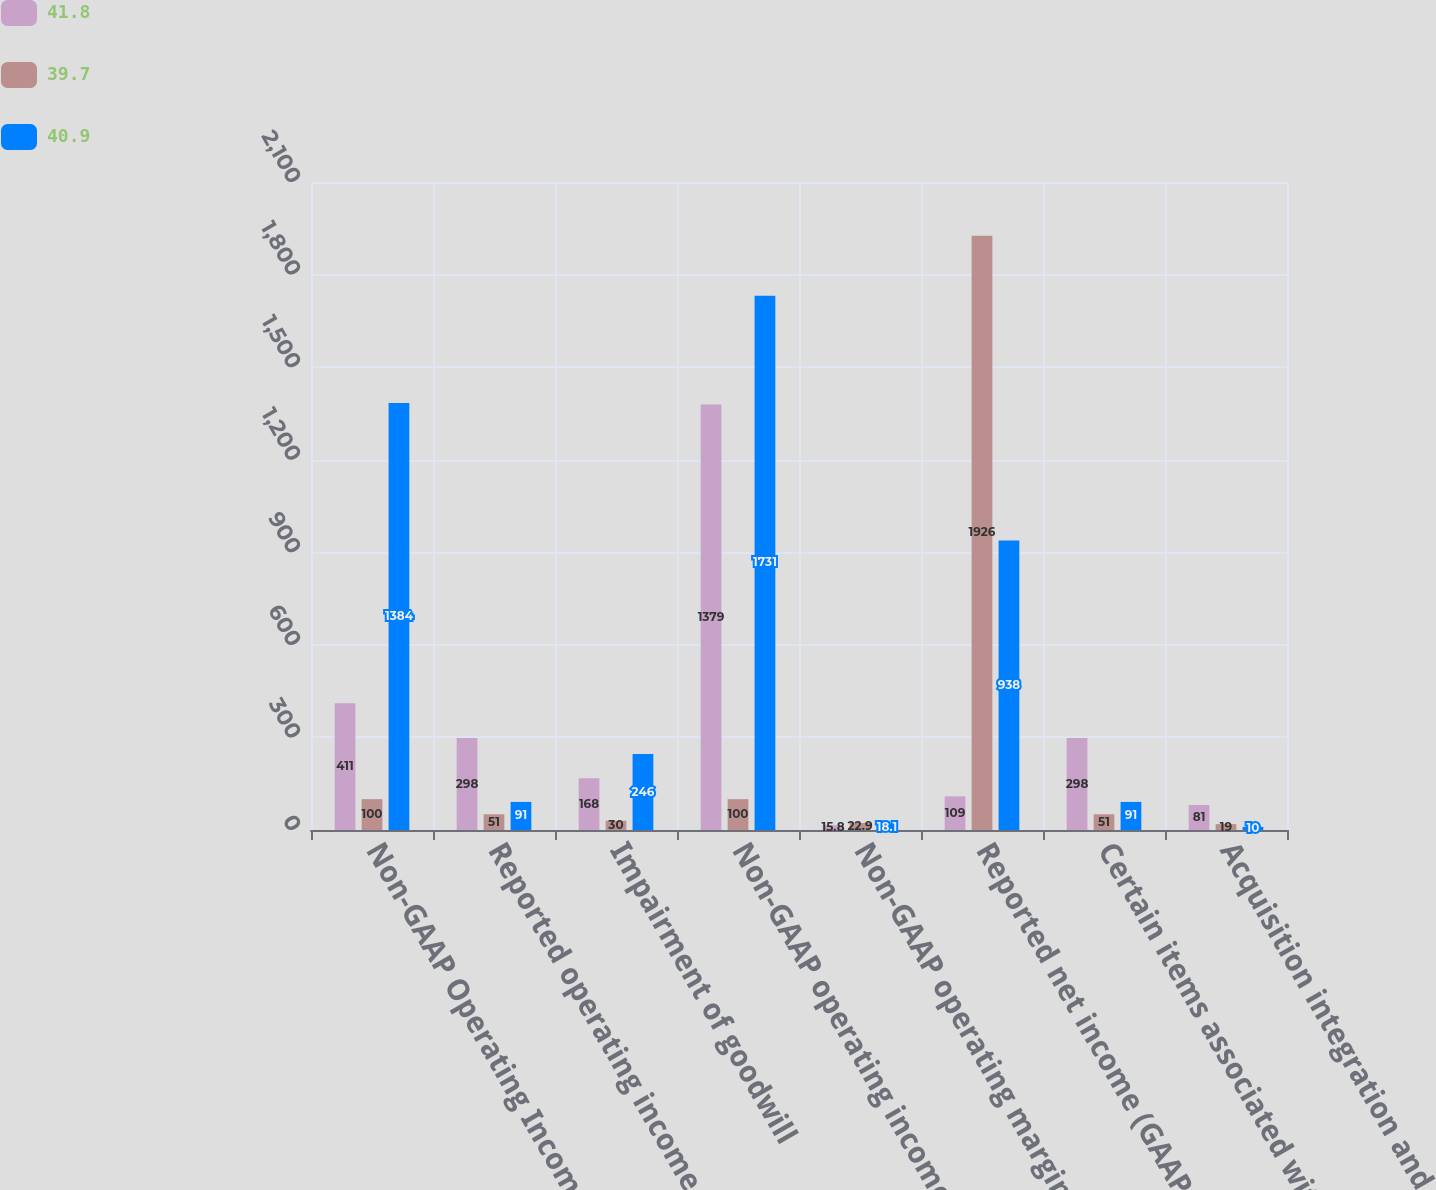<chart> <loc_0><loc_0><loc_500><loc_500><stacked_bar_chart><ecel><fcel>Non-GAAP Operating Income<fcel>Reported operating income<fcel>Impairment of goodwill<fcel>Non-GAAP operating income<fcel>Non-GAAP operating margin<fcel>Reported net income (GAAP<fcel>Certain items associated with<fcel>Acquisition integration and<nl><fcel>41.8<fcel>411<fcel>298<fcel>168<fcel>1379<fcel>15.8<fcel>109<fcel>298<fcel>81<nl><fcel>39.7<fcel>100<fcel>51<fcel>30<fcel>100<fcel>22.9<fcel>1926<fcel>51<fcel>19<nl><fcel>40.9<fcel>1384<fcel>91<fcel>246<fcel>1731<fcel>18.1<fcel>938<fcel>91<fcel>10<nl></chart> 